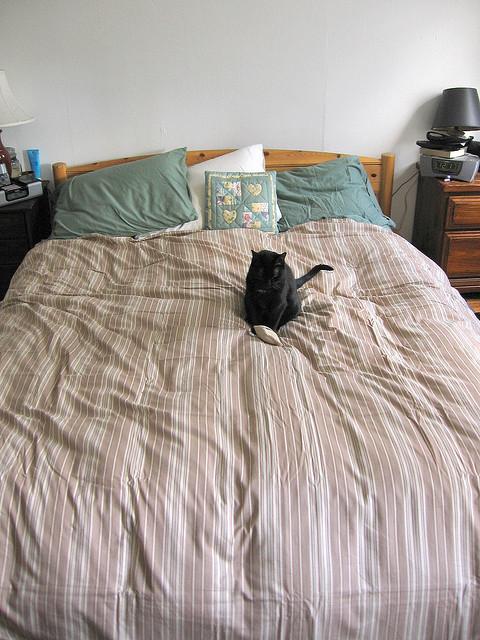How well was this bed made?
Short answer required. Not very. Are the all pillows the same size?
Answer briefly. No. What type of animal is near the pillows?
Answer briefly. Cat. What animal is on the bed?
Quick response, please. Cat. 